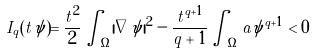<formula> <loc_0><loc_0><loc_500><loc_500>I _ { q } ( t \psi ) = \frac { t ^ { 2 } } { 2 } \int _ { \Omega } | \nabla \psi | ^ { 2 } - \frac { t ^ { q + 1 } } { q + 1 } \int _ { \Omega } a \psi ^ { q + 1 } < 0</formula> 